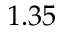<formula> <loc_0><loc_0><loc_500><loc_500>1 . 3 5</formula> 